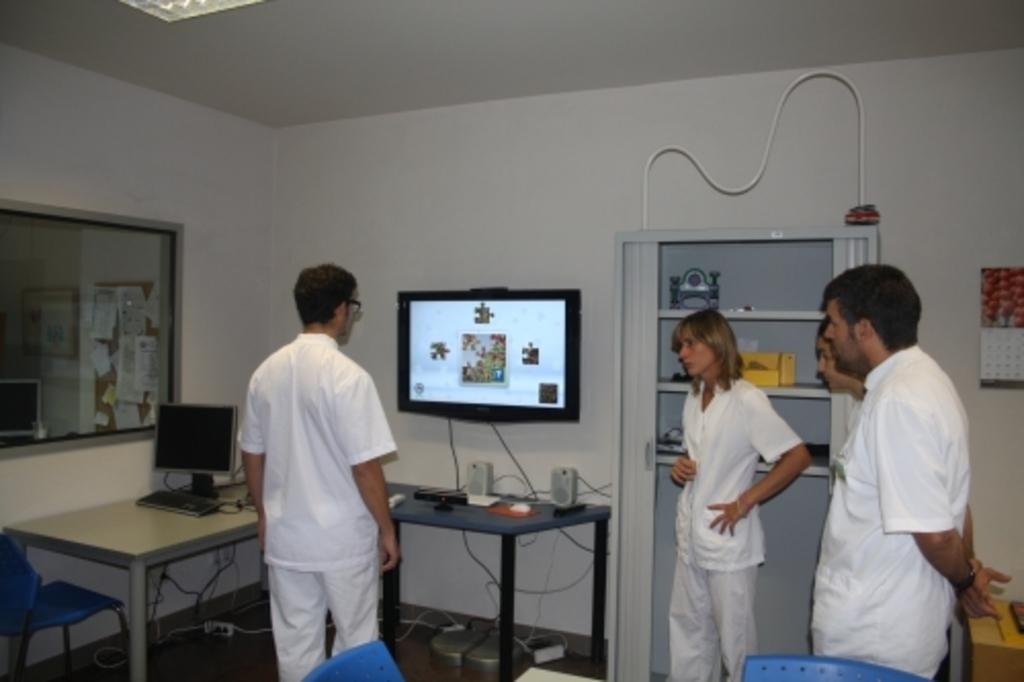How many people are in the image? There are four persons in the image. What are the persons doing in the image? The persons are standing in the image. What objects are in front of the persons? There are tables in front of the persons. What electronic devices can be seen on the table? There is a monitor, two speakers, and a TV on the table. What type of furniture is present in the image? There are chairs in the image. What type of prose is being read by the persons in the image? There is no indication in the image that the persons are reading any prose. Can you see a worm crawling on the table in the image? There is no worm present in the image. 